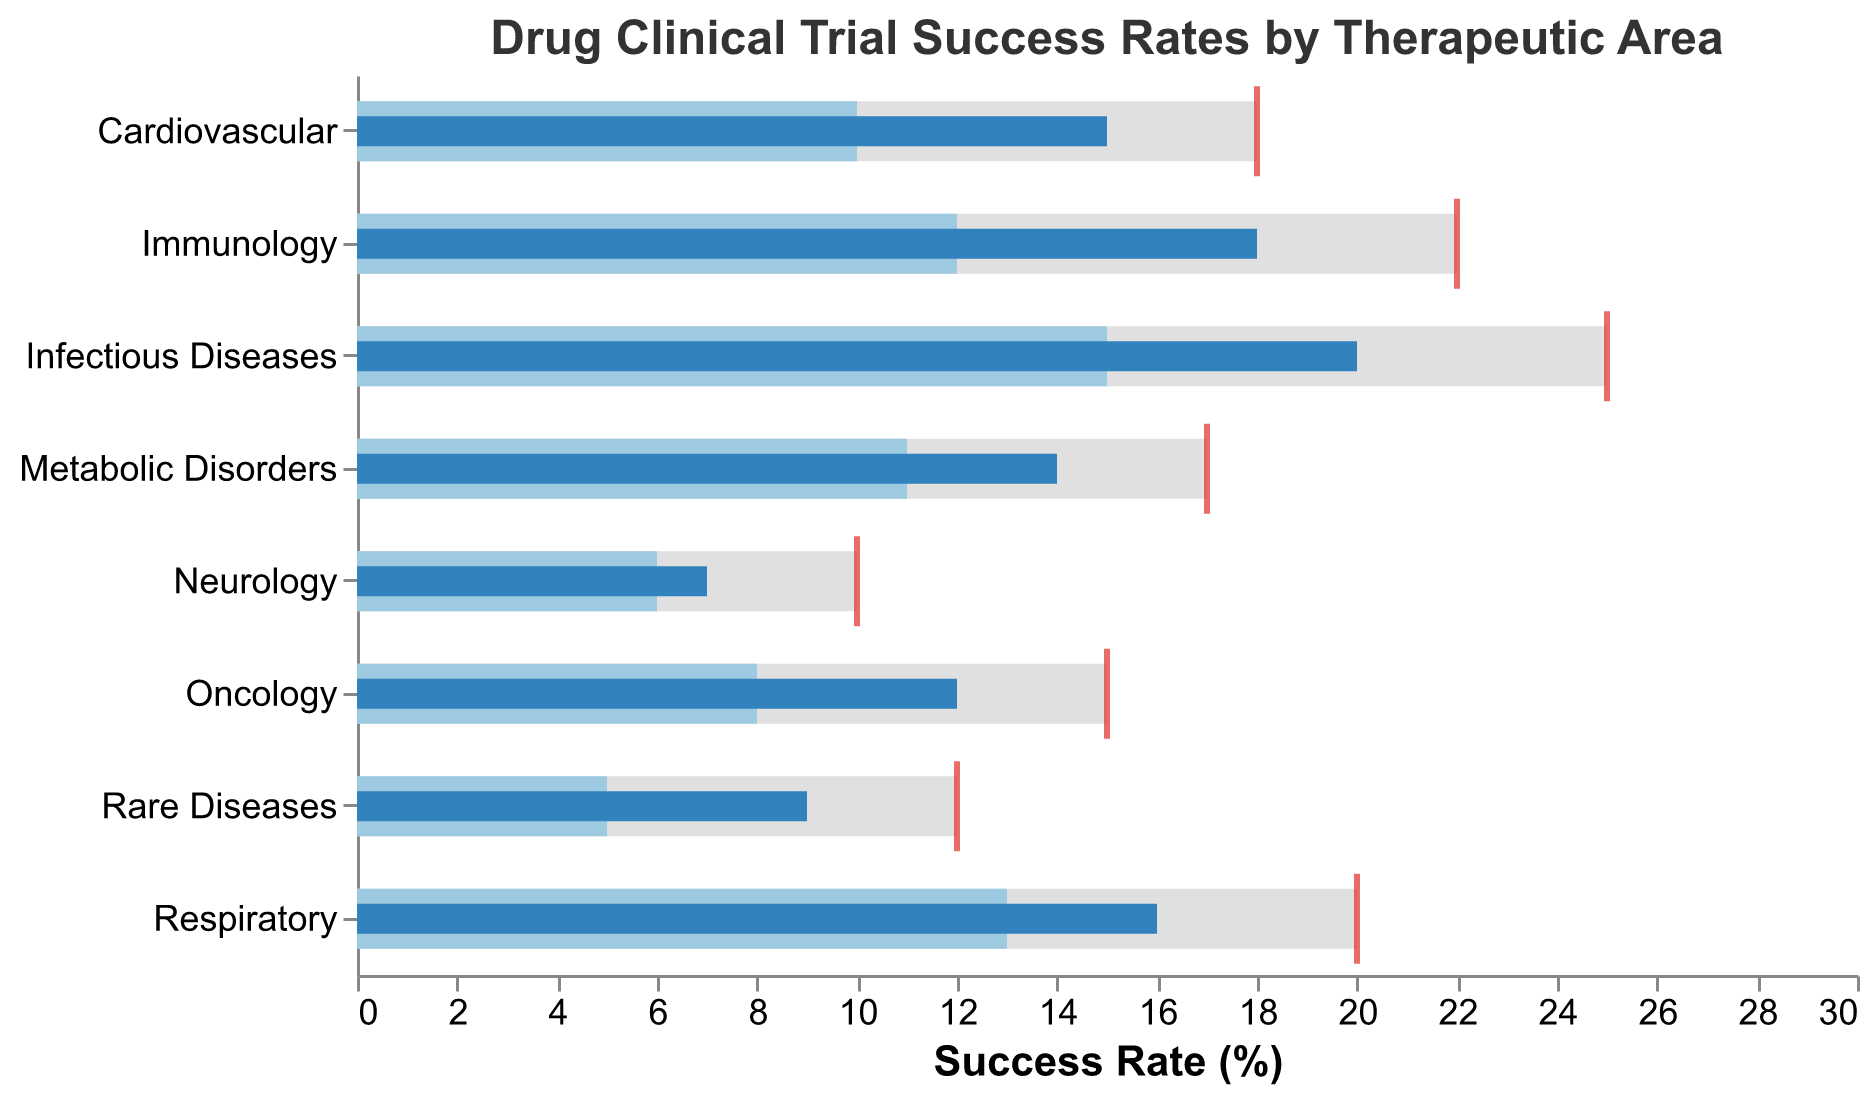What is the title of the chart? The title of the chart is directly visible at the top of the figure.
Answer: Drug Clinical Trial Success Rates by Therapeutic Area Which therapeutic area has the highest actual success rate? By examining the bar heights corresponding to the "Actual Success Rate", it is clear that "Infectious Diseases" has the tallest bar.
Answer: Infectious Diseases What is the industry average success rate for Neurology? Locate the bar segment labelled "Neurology" and identify the secondary bar representing the industry average success rate.
Answer: 6 How does the actual success rate for Oncology compare to its target? Compare the actual success rate bar of Oncology (12) with its target rate (red tick mark at 15). The actual rate is slightly below the target.
Answer: Below target Which therapeutic area has the smallest difference between its actual success rate and the industry average? Calculate the differences for each area and identify the smallest one. Neurology's difference is 1 (7 - 6 = 1).
Answer: Neurology For Immunology, what is the gap between the actual success rate and the target rate? Subtract the actual success rate (18) from the target rate (22).
Answer: 4 Do any therapeutic areas exceed their target success rate? Compare each therapeutic area’s actual success rate bar against its respective target (red tick marks). None exceed their target.
Answer: No How many therapeutic areas have an actual success rate that exceeds the industry average? Count the number of instances where the "Actual Success Rate" bar exceeds the "Industry Average" bar: Four areas (Cardiovascular, Infectious Diseases, Immunology, Respiratory).
Answer: 4 What is the difference between the actual success rate and the industry average for Rare Diseases? Subtract the industry average rate of Rare Diseases (5) from its actual success rate (9).
Answer: 4 Which therapeutic area has the highest target success rate? Identify the therapeutic area with the farthest right red tick mark, which represents the highest target rate.
Answer: Infectious Diseases 